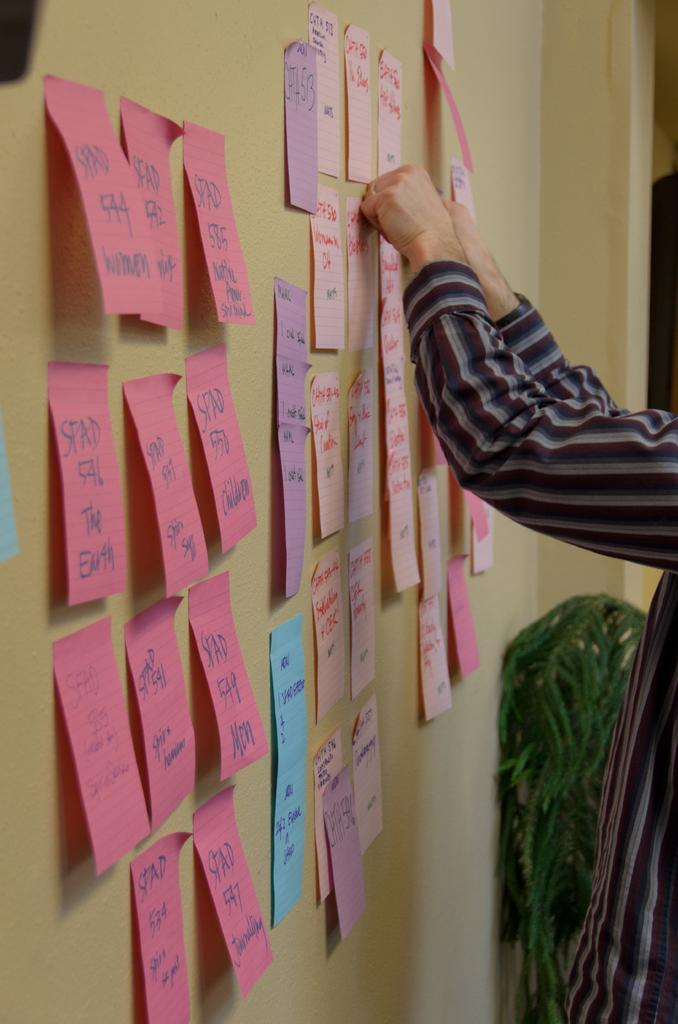What is on the papers that are visible in the image? The papers have writing on them in the image. Where are the papers with writing located? The papers are attached to the wall in the left corner of the image. Can you describe the person in the image? There is a person standing in the right corner of the image. What type of jelly is being used to grade the papers in the image? There is no jelly present in the image, and the papers are not being graded. 